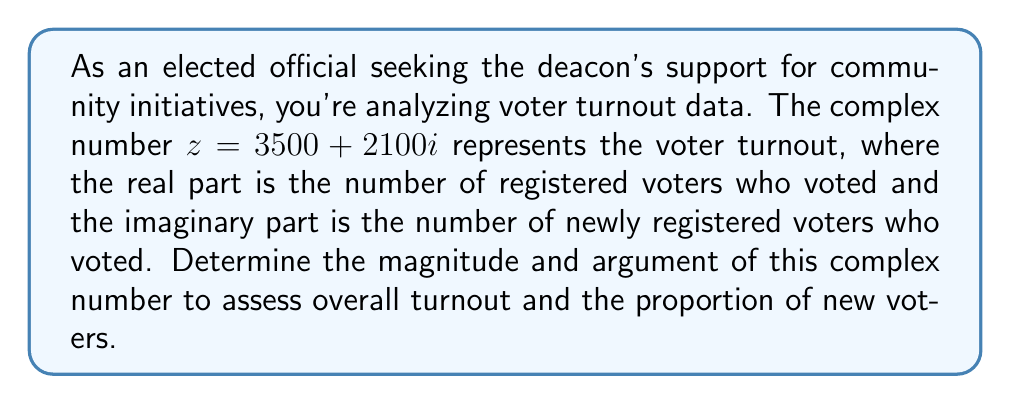Can you answer this question? To find the magnitude and argument of the complex number $z = 3500 + 2100i$, we'll follow these steps:

1. Magnitude (r):
   The magnitude is given by the formula: $r = \sqrt{a^2 + b^2}$, where $a$ is the real part and $b$ is the imaginary part.

   $$r = \sqrt{3500^2 + 2100^2}$$
   $$r = \sqrt{12,250,000 + 4,410,000}$$
   $$r = \sqrt{16,660,000}$$
   $$r = 4,082.72$$ (rounded to 2 decimal places)

2. Argument (θ):
   The argument is given by the formula: $\theta = \tan^{-1}(\frac{b}{a})$, where $a$ is the real part and $b$ is the imaginary part.

   $$\theta = \tan^{-1}(\frac{2100}{3500})$$
   $$\theta = 0.5404$$ radians (rounded to 4 decimal places)

   To convert to degrees:
   $$\theta = 0.5404 \times \frac{180}{\pi} = 30.96°$$ (rounded to 2 decimal places)

The magnitude represents the total voter turnout, while the argument represents the angle formed by the complex number in the complex plane, which gives an indication of the proportion of new voters to total voters.
Answer: Magnitude: $4,082.72$
Argument: $0.5404$ radians or $30.96°$ 